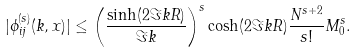<formula> <loc_0><loc_0><loc_500><loc_500>| \phi _ { i j } ^ { ( s ) } ( k , x ) | \leq \left ( \frac { \sinh ( 2 \Im { k } R ) } { \Im { k } } \right ) ^ { s } \cosh ( 2 \Im { k } R ) \frac { N ^ { s + 2 } } { s ! } M _ { 0 } ^ { s } .</formula> 